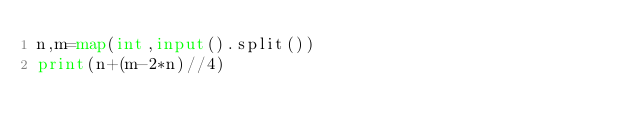Convert code to text. <code><loc_0><loc_0><loc_500><loc_500><_Python_>n,m=map(int,input().split())
print(n+(m-2*n)//4)</code> 